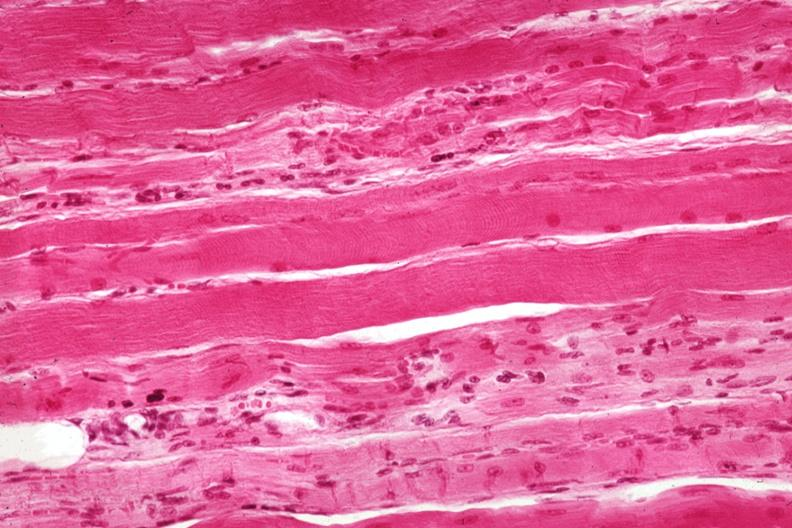s soft tissue present?
Answer the question using a single word or phrase. Yes 